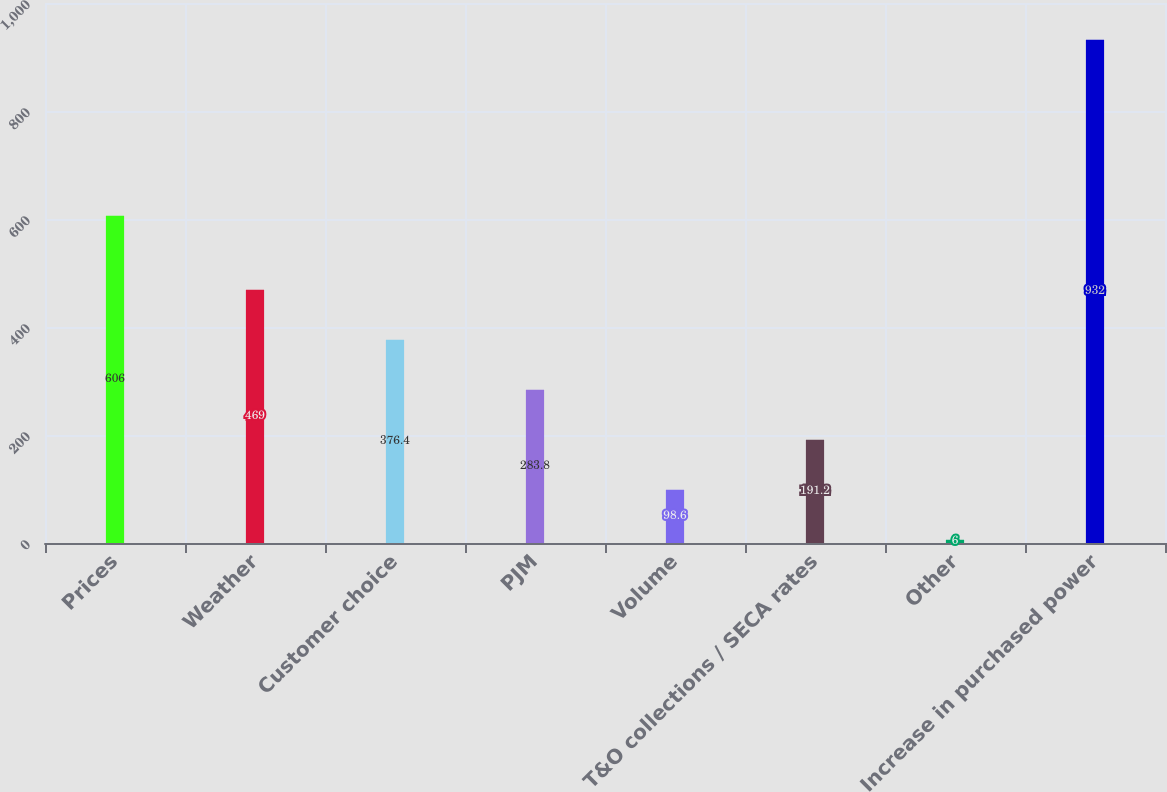Convert chart. <chart><loc_0><loc_0><loc_500><loc_500><bar_chart><fcel>Prices<fcel>Weather<fcel>Customer choice<fcel>PJM<fcel>Volume<fcel>T&O collections / SECA rates<fcel>Other<fcel>Increase in purchased power<nl><fcel>606<fcel>469<fcel>376.4<fcel>283.8<fcel>98.6<fcel>191.2<fcel>6<fcel>932<nl></chart> 